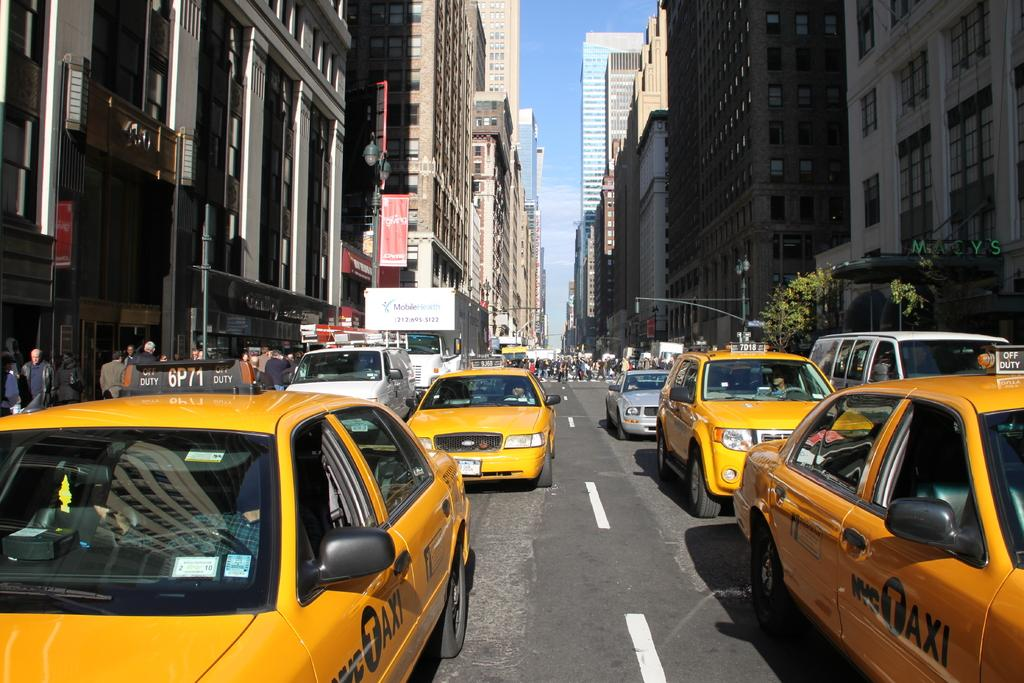Provide a one-sentence caption for the provided image. A street in NY with multiple yellow NYC TAXIs. 